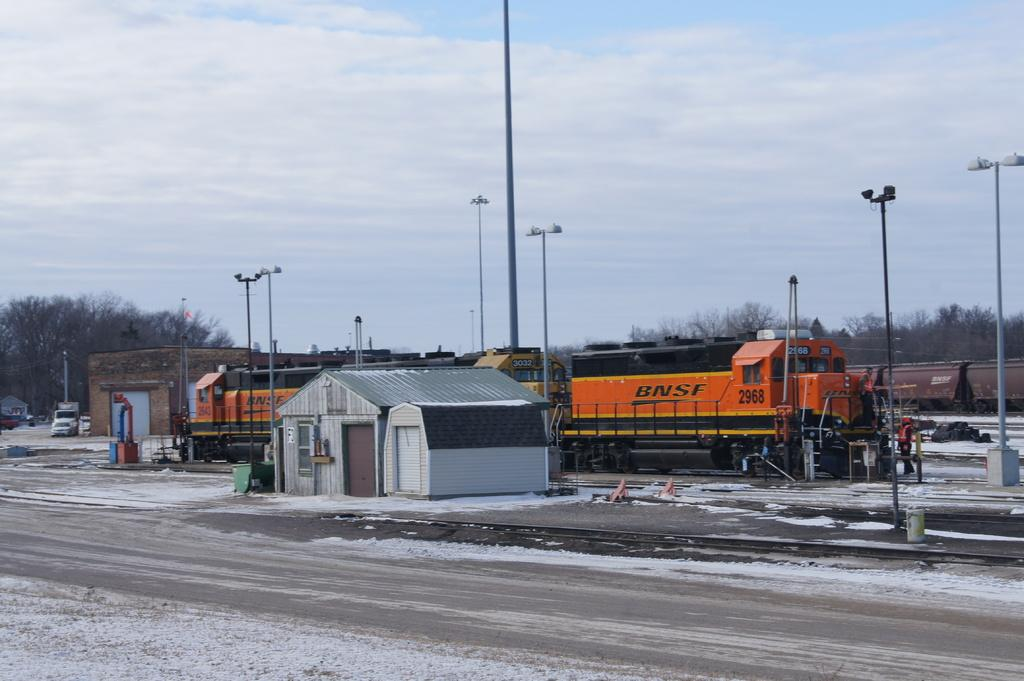<image>
Summarize the visual content of the image. An small, orange BNSF train passes through a station. 